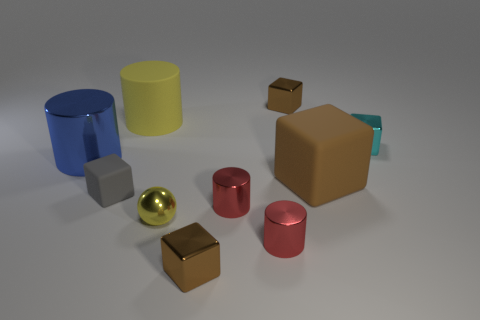Subtract all brown spheres. How many red cylinders are left? 2 Subtract all shiny cylinders. How many cylinders are left? 1 Subtract all gray blocks. How many blocks are left? 4 Subtract all purple blocks. Subtract all green cylinders. How many blocks are left? 5 Subtract all spheres. How many objects are left? 9 Add 7 tiny cyan things. How many tiny cyan things exist? 8 Subtract 1 yellow balls. How many objects are left? 9 Subtract all tiny gray rubber blocks. Subtract all big cylinders. How many objects are left? 7 Add 6 big blue shiny cylinders. How many big blue shiny cylinders are left? 7 